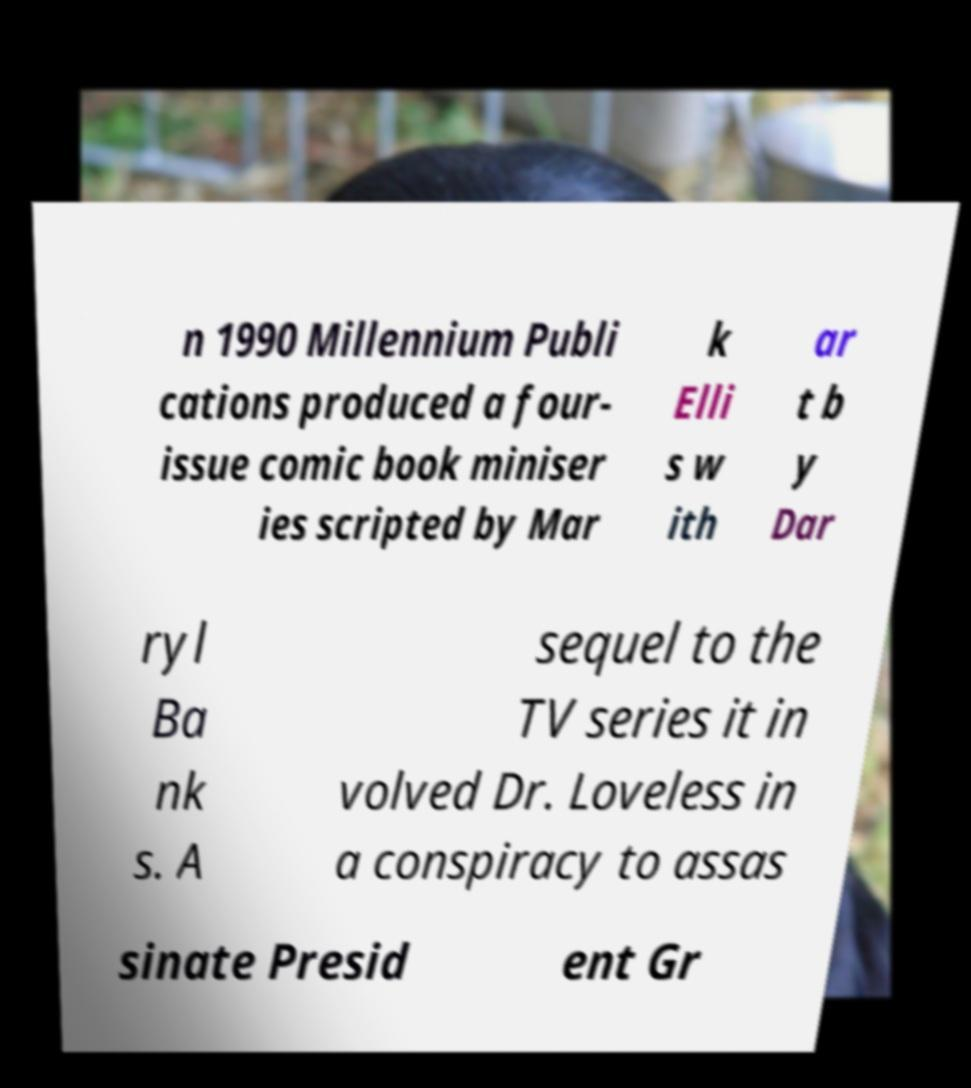Could you extract and type out the text from this image? n 1990 Millennium Publi cations produced a four- issue comic book miniser ies scripted by Mar k Elli s w ith ar t b y Dar ryl Ba nk s. A sequel to the TV series it in volved Dr. Loveless in a conspiracy to assas sinate Presid ent Gr 